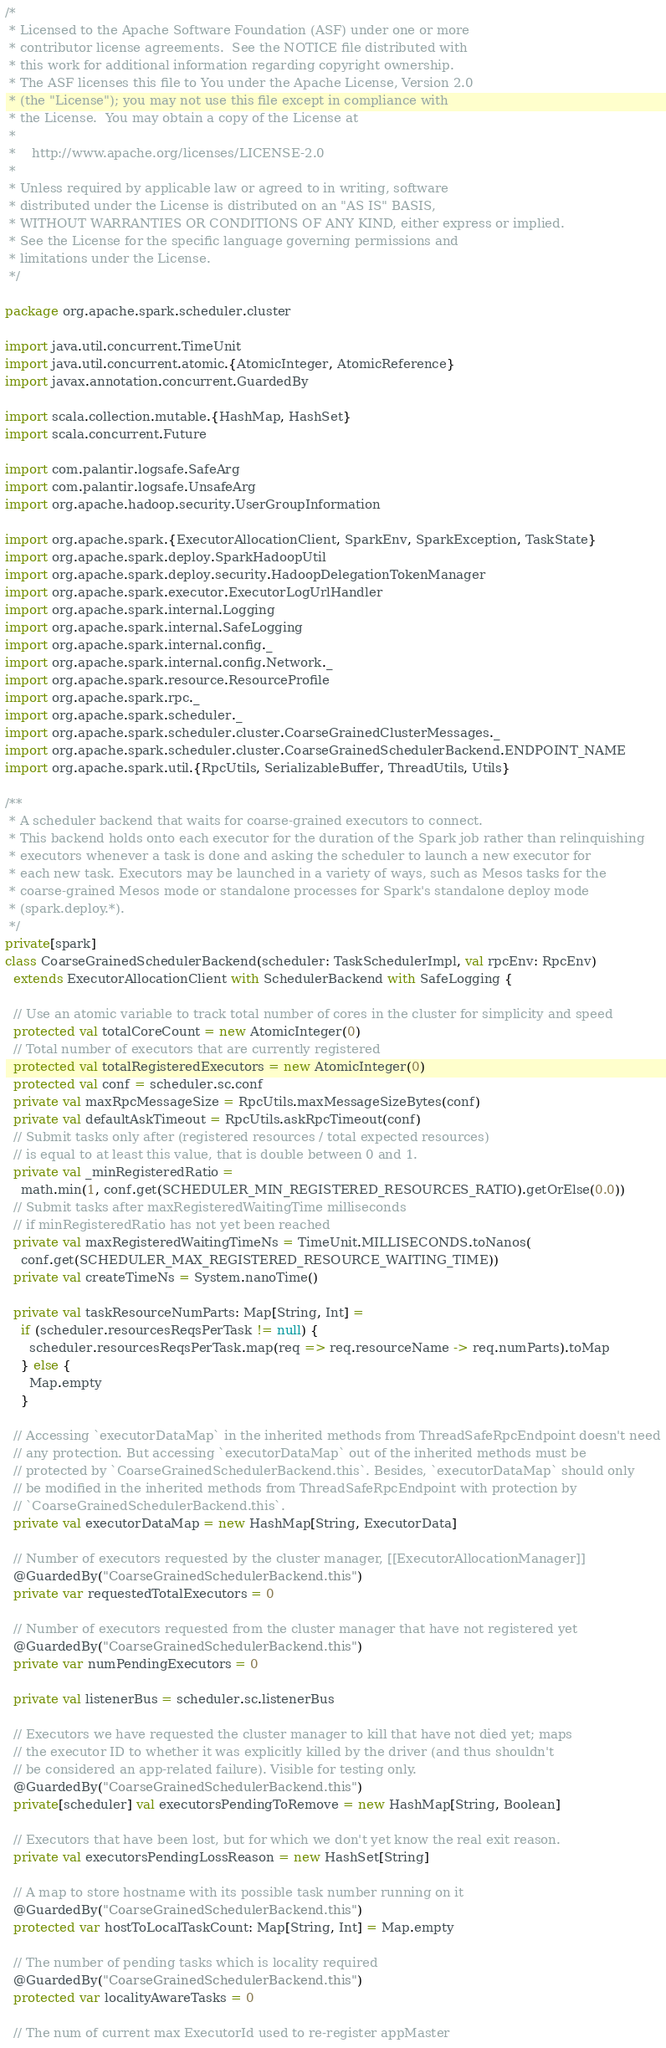Convert code to text. <code><loc_0><loc_0><loc_500><loc_500><_Scala_>/*
 * Licensed to the Apache Software Foundation (ASF) under one or more
 * contributor license agreements.  See the NOTICE file distributed with
 * this work for additional information regarding copyright ownership.
 * The ASF licenses this file to You under the Apache License, Version 2.0
 * (the "License"); you may not use this file except in compliance with
 * the License.  You may obtain a copy of the License at
 *
 *    http://www.apache.org/licenses/LICENSE-2.0
 *
 * Unless required by applicable law or agreed to in writing, software
 * distributed under the License is distributed on an "AS IS" BASIS,
 * WITHOUT WARRANTIES OR CONDITIONS OF ANY KIND, either express or implied.
 * See the License for the specific language governing permissions and
 * limitations under the License.
 */

package org.apache.spark.scheduler.cluster

import java.util.concurrent.TimeUnit
import java.util.concurrent.atomic.{AtomicInteger, AtomicReference}
import javax.annotation.concurrent.GuardedBy

import scala.collection.mutable.{HashMap, HashSet}
import scala.concurrent.Future

import com.palantir.logsafe.SafeArg
import com.palantir.logsafe.UnsafeArg
import org.apache.hadoop.security.UserGroupInformation

import org.apache.spark.{ExecutorAllocationClient, SparkEnv, SparkException, TaskState}
import org.apache.spark.deploy.SparkHadoopUtil
import org.apache.spark.deploy.security.HadoopDelegationTokenManager
import org.apache.spark.executor.ExecutorLogUrlHandler
import org.apache.spark.internal.Logging
import org.apache.spark.internal.SafeLogging
import org.apache.spark.internal.config._
import org.apache.spark.internal.config.Network._
import org.apache.spark.resource.ResourceProfile
import org.apache.spark.rpc._
import org.apache.spark.scheduler._
import org.apache.spark.scheduler.cluster.CoarseGrainedClusterMessages._
import org.apache.spark.scheduler.cluster.CoarseGrainedSchedulerBackend.ENDPOINT_NAME
import org.apache.spark.util.{RpcUtils, SerializableBuffer, ThreadUtils, Utils}

/**
 * A scheduler backend that waits for coarse-grained executors to connect.
 * This backend holds onto each executor for the duration of the Spark job rather than relinquishing
 * executors whenever a task is done and asking the scheduler to launch a new executor for
 * each new task. Executors may be launched in a variety of ways, such as Mesos tasks for the
 * coarse-grained Mesos mode or standalone processes for Spark's standalone deploy mode
 * (spark.deploy.*).
 */
private[spark]
class CoarseGrainedSchedulerBackend(scheduler: TaskSchedulerImpl, val rpcEnv: RpcEnv)
  extends ExecutorAllocationClient with SchedulerBackend with SafeLogging {

  // Use an atomic variable to track total number of cores in the cluster for simplicity and speed
  protected val totalCoreCount = new AtomicInteger(0)
  // Total number of executors that are currently registered
  protected val totalRegisteredExecutors = new AtomicInteger(0)
  protected val conf = scheduler.sc.conf
  private val maxRpcMessageSize = RpcUtils.maxMessageSizeBytes(conf)
  private val defaultAskTimeout = RpcUtils.askRpcTimeout(conf)
  // Submit tasks only after (registered resources / total expected resources)
  // is equal to at least this value, that is double between 0 and 1.
  private val _minRegisteredRatio =
    math.min(1, conf.get(SCHEDULER_MIN_REGISTERED_RESOURCES_RATIO).getOrElse(0.0))
  // Submit tasks after maxRegisteredWaitingTime milliseconds
  // if minRegisteredRatio has not yet been reached
  private val maxRegisteredWaitingTimeNs = TimeUnit.MILLISECONDS.toNanos(
    conf.get(SCHEDULER_MAX_REGISTERED_RESOURCE_WAITING_TIME))
  private val createTimeNs = System.nanoTime()

  private val taskResourceNumParts: Map[String, Int] =
    if (scheduler.resourcesReqsPerTask != null) {
      scheduler.resourcesReqsPerTask.map(req => req.resourceName -> req.numParts).toMap
    } else {
      Map.empty
    }

  // Accessing `executorDataMap` in the inherited methods from ThreadSafeRpcEndpoint doesn't need
  // any protection. But accessing `executorDataMap` out of the inherited methods must be
  // protected by `CoarseGrainedSchedulerBackend.this`. Besides, `executorDataMap` should only
  // be modified in the inherited methods from ThreadSafeRpcEndpoint with protection by
  // `CoarseGrainedSchedulerBackend.this`.
  private val executorDataMap = new HashMap[String, ExecutorData]

  // Number of executors requested by the cluster manager, [[ExecutorAllocationManager]]
  @GuardedBy("CoarseGrainedSchedulerBackend.this")
  private var requestedTotalExecutors = 0

  // Number of executors requested from the cluster manager that have not registered yet
  @GuardedBy("CoarseGrainedSchedulerBackend.this")
  private var numPendingExecutors = 0

  private val listenerBus = scheduler.sc.listenerBus

  // Executors we have requested the cluster manager to kill that have not died yet; maps
  // the executor ID to whether it was explicitly killed by the driver (and thus shouldn't
  // be considered an app-related failure). Visible for testing only.
  @GuardedBy("CoarseGrainedSchedulerBackend.this")
  private[scheduler] val executorsPendingToRemove = new HashMap[String, Boolean]

  // Executors that have been lost, but for which we don't yet know the real exit reason.
  private val executorsPendingLossReason = new HashSet[String]

  // A map to store hostname with its possible task number running on it
  @GuardedBy("CoarseGrainedSchedulerBackend.this")
  protected var hostToLocalTaskCount: Map[String, Int] = Map.empty

  // The number of pending tasks which is locality required
  @GuardedBy("CoarseGrainedSchedulerBackend.this")
  protected var localityAwareTasks = 0

  // The num of current max ExecutorId used to re-register appMaster</code> 